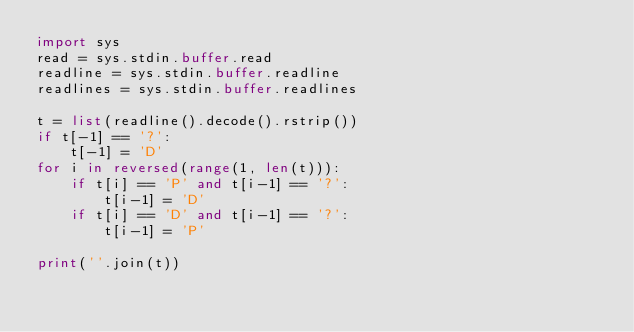Convert code to text. <code><loc_0><loc_0><loc_500><loc_500><_Python_>import sys
read = sys.stdin.buffer.read
readline = sys.stdin.buffer.readline
readlines = sys.stdin.buffer.readlines

t = list(readline().decode().rstrip())
if t[-1] == '?':
    t[-1] = 'D'
for i in reversed(range(1, len(t))):
    if t[i] == 'P' and t[i-1] == '?':
        t[i-1] = 'D'
    if t[i] == 'D' and t[i-1] == '?':
        t[i-1] = 'P'

print(''.join(t))
</code> 